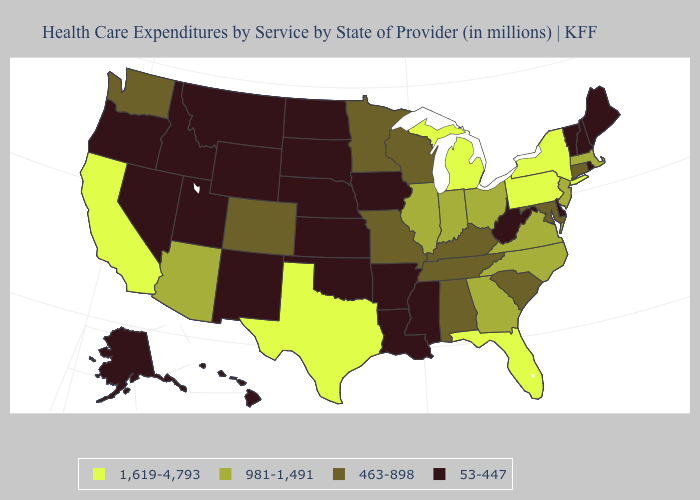Name the states that have a value in the range 463-898?
Be succinct. Alabama, Colorado, Connecticut, Kentucky, Maryland, Minnesota, Missouri, South Carolina, Tennessee, Washington, Wisconsin. Among the states that border New Jersey , does Delaware have the highest value?
Write a very short answer. No. Name the states that have a value in the range 53-447?
Be succinct. Alaska, Arkansas, Delaware, Hawaii, Idaho, Iowa, Kansas, Louisiana, Maine, Mississippi, Montana, Nebraska, Nevada, New Hampshire, New Mexico, North Dakota, Oklahoma, Oregon, Rhode Island, South Dakota, Utah, Vermont, West Virginia, Wyoming. Does New Hampshire have the highest value in the Northeast?
Answer briefly. No. Which states have the lowest value in the USA?
Write a very short answer. Alaska, Arkansas, Delaware, Hawaii, Idaho, Iowa, Kansas, Louisiana, Maine, Mississippi, Montana, Nebraska, Nevada, New Hampshire, New Mexico, North Dakota, Oklahoma, Oregon, Rhode Island, South Dakota, Utah, Vermont, West Virginia, Wyoming. What is the value of New Hampshire?
Short answer required. 53-447. What is the value of Georgia?
Answer briefly. 981-1,491. Name the states that have a value in the range 463-898?
Give a very brief answer. Alabama, Colorado, Connecticut, Kentucky, Maryland, Minnesota, Missouri, South Carolina, Tennessee, Washington, Wisconsin. Among the states that border New York , which have the lowest value?
Give a very brief answer. Vermont. What is the value of Alabama?
Give a very brief answer. 463-898. How many symbols are there in the legend?
Concise answer only. 4. What is the value of Montana?
Answer briefly. 53-447. Name the states that have a value in the range 1,619-4,793?
Answer briefly. California, Florida, Michigan, New York, Pennsylvania, Texas. Does Michigan have the highest value in the MidWest?
Keep it brief. Yes. 